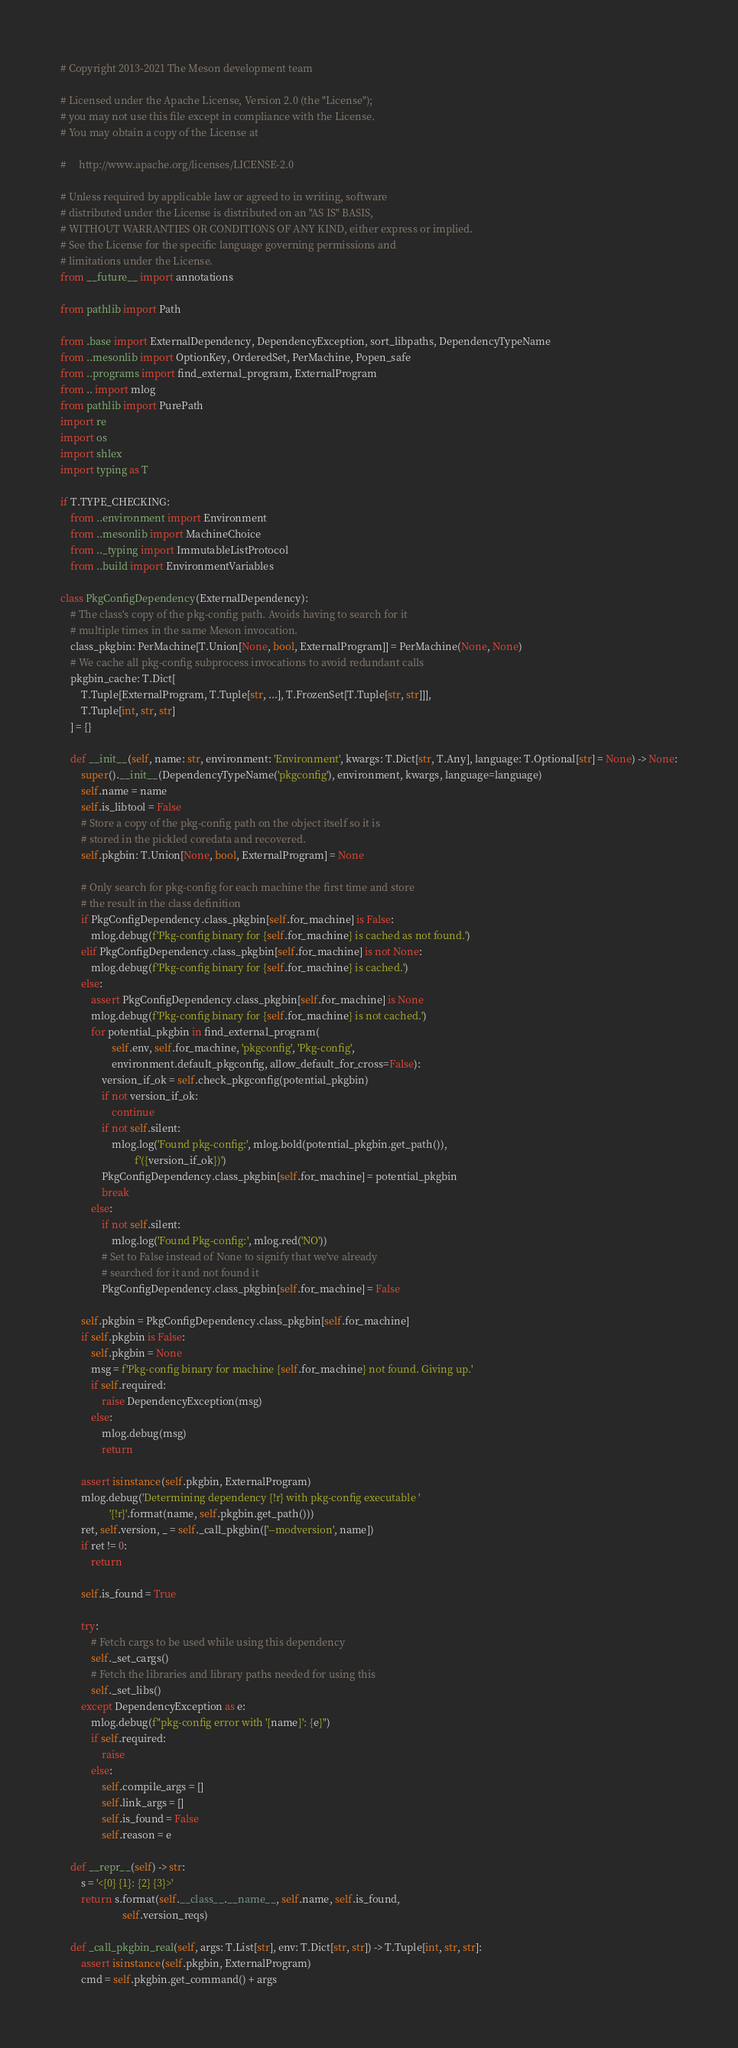<code> <loc_0><loc_0><loc_500><loc_500><_Python_># Copyright 2013-2021 The Meson development team

# Licensed under the Apache License, Version 2.0 (the "License");
# you may not use this file except in compliance with the License.
# You may obtain a copy of the License at

#     http://www.apache.org/licenses/LICENSE-2.0

# Unless required by applicable law or agreed to in writing, software
# distributed under the License is distributed on an "AS IS" BASIS,
# WITHOUT WARRANTIES OR CONDITIONS OF ANY KIND, either express or implied.
# See the License for the specific language governing permissions and
# limitations under the License.
from __future__ import annotations

from pathlib import Path

from .base import ExternalDependency, DependencyException, sort_libpaths, DependencyTypeName
from ..mesonlib import OptionKey, OrderedSet, PerMachine, Popen_safe
from ..programs import find_external_program, ExternalProgram
from .. import mlog
from pathlib import PurePath
import re
import os
import shlex
import typing as T

if T.TYPE_CHECKING:
    from ..environment import Environment
    from ..mesonlib import MachineChoice
    from .._typing import ImmutableListProtocol
    from ..build import EnvironmentVariables

class PkgConfigDependency(ExternalDependency):
    # The class's copy of the pkg-config path. Avoids having to search for it
    # multiple times in the same Meson invocation.
    class_pkgbin: PerMachine[T.Union[None, bool, ExternalProgram]] = PerMachine(None, None)
    # We cache all pkg-config subprocess invocations to avoid redundant calls
    pkgbin_cache: T.Dict[
        T.Tuple[ExternalProgram, T.Tuple[str, ...], T.FrozenSet[T.Tuple[str, str]]],
        T.Tuple[int, str, str]
    ] = {}

    def __init__(self, name: str, environment: 'Environment', kwargs: T.Dict[str, T.Any], language: T.Optional[str] = None) -> None:
        super().__init__(DependencyTypeName('pkgconfig'), environment, kwargs, language=language)
        self.name = name
        self.is_libtool = False
        # Store a copy of the pkg-config path on the object itself so it is
        # stored in the pickled coredata and recovered.
        self.pkgbin: T.Union[None, bool, ExternalProgram] = None

        # Only search for pkg-config for each machine the first time and store
        # the result in the class definition
        if PkgConfigDependency.class_pkgbin[self.for_machine] is False:
            mlog.debug(f'Pkg-config binary for {self.for_machine} is cached as not found.')
        elif PkgConfigDependency.class_pkgbin[self.for_machine] is not None:
            mlog.debug(f'Pkg-config binary for {self.for_machine} is cached.')
        else:
            assert PkgConfigDependency.class_pkgbin[self.for_machine] is None
            mlog.debug(f'Pkg-config binary for {self.for_machine} is not cached.')
            for potential_pkgbin in find_external_program(
                    self.env, self.for_machine, 'pkgconfig', 'Pkg-config',
                    environment.default_pkgconfig, allow_default_for_cross=False):
                version_if_ok = self.check_pkgconfig(potential_pkgbin)
                if not version_if_ok:
                    continue
                if not self.silent:
                    mlog.log('Found pkg-config:', mlog.bold(potential_pkgbin.get_path()),
                             f'({version_if_ok})')
                PkgConfigDependency.class_pkgbin[self.for_machine] = potential_pkgbin
                break
            else:
                if not self.silent:
                    mlog.log('Found Pkg-config:', mlog.red('NO'))
                # Set to False instead of None to signify that we've already
                # searched for it and not found it
                PkgConfigDependency.class_pkgbin[self.for_machine] = False

        self.pkgbin = PkgConfigDependency.class_pkgbin[self.for_machine]
        if self.pkgbin is False:
            self.pkgbin = None
            msg = f'Pkg-config binary for machine {self.for_machine} not found. Giving up.'
            if self.required:
                raise DependencyException(msg)
            else:
                mlog.debug(msg)
                return

        assert isinstance(self.pkgbin, ExternalProgram)
        mlog.debug('Determining dependency {!r} with pkg-config executable '
                   '{!r}'.format(name, self.pkgbin.get_path()))
        ret, self.version, _ = self._call_pkgbin(['--modversion', name])
        if ret != 0:
            return

        self.is_found = True

        try:
            # Fetch cargs to be used while using this dependency
            self._set_cargs()
            # Fetch the libraries and library paths needed for using this
            self._set_libs()
        except DependencyException as e:
            mlog.debug(f"pkg-config error with '{name}': {e}")
            if self.required:
                raise
            else:
                self.compile_args = []
                self.link_args = []
                self.is_found = False
                self.reason = e

    def __repr__(self) -> str:
        s = '<{0} {1}: {2} {3}>'
        return s.format(self.__class__.__name__, self.name, self.is_found,
                        self.version_reqs)

    def _call_pkgbin_real(self, args: T.List[str], env: T.Dict[str, str]) -> T.Tuple[int, str, str]:
        assert isinstance(self.pkgbin, ExternalProgram)
        cmd = self.pkgbin.get_command() + args</code> 